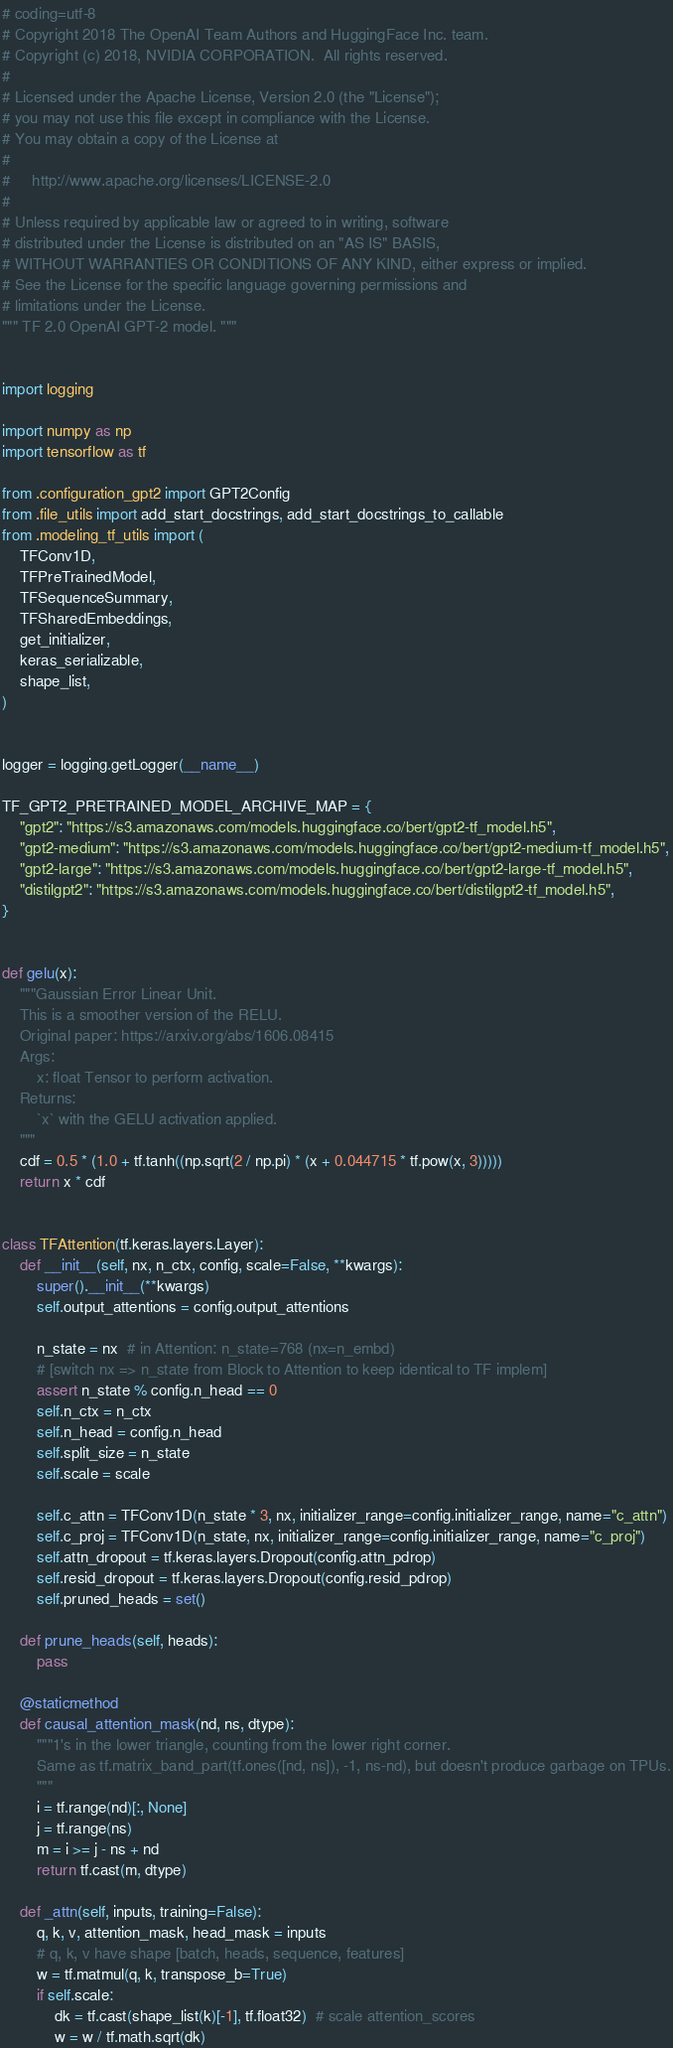<code> <loc_0><loc_0><loc_500><loc_500><_Python_># coding=utf-8
# Copyright 2018 The OpenAI Team Authors and HuggingFace Inc. team.
# Copyright (c) 2018, NVIDIA CORPORATION.  All rights reserved.
#
# Licensed under the Apache License, Version 2.0 (the "License");
# you may not use this file except in compliance with the License.
# You may obtain a copy of the License at
#
#     http://www.apache.org/licenses/LICENSE-2.0
#
# Unless required by applicable law or agreed to in writing, software
# distributed under the License is distributed on an "AS IS" BASIS,
# WITHOUT WARRANTIES OR CONDITIONS OF ANY KIND, either express or implied.
# See the License for the specific language governing permissions and
# limitations under the License.
""" TF 2.0 OpenAI GPT-2 model. """


import logging

import numpy as np
import tensorflow as tf

from .configuration_gpt2 import GPT2Config
from .file_utils import add_start_docstrings, add_start_docstrings_to_callable
from .modeling_tf_utils import (
    TFConv1D,
    TFPreTrainedModel,
    TFSequenceSummary,
    TFSharedEmbeddings,
    get_initializer,
    keras_serializable,
    shape_list,
)


logger = logging.getLogger(__name__)

TF_GPT2_PRETRAINED_MODEL_ARCHIVE_MAP = {
    "gpt2": "https://s3.amazonaws.com/models.huggingface.co/bert/gpt2-tf_model.h5",
    "gpt2-medium": "https://s3.amazonaws.com/models.huggingface.co/bert/gpt2-medium-tf_model.h5",
    "gpt2-large": "https://s3.amazonaws.com/models.huggingface.co/bert/gpt2-large-tf_model.h5",
    "distilgpt2": "https://s3.amazonaws.com/models.huggingface.co/bert/distilgpt2-tf_model.h5",
}


def gelu(x):
    """Gaussian Error Linear Unit.
    This is a smoother version of the RELU.
    Original paper: https://arxiv.org/abs/1606.08415
    Args:
        x: float Tensor to perform activation.
    Returns:
        `x` with the GELU activation applied.
    """
    cdf = 0.5 * (1.0 + tf.tanh((np.sqrt(2 / np.pi) * (x + 0.044715 * tf.pow(x, 3)))))
    return x * cdf


class TFAttention(tf.keras.layers.Layer):
    def __init__(self, nx, n_ctx, config, scale=False, **kwargs):
        super().__init__(**kwargs)
        self.output_attentions = config.output_attentions

        n_state = nx  # in Attention: n_state=768 (nx=n_embd)
        # [switch nx => n_state from Block to Attention to keep identical to TF implem]
        assert n_state % config.n_head == 0
        self.n_ctx = n_ctx
        self.n_head = config.n_head
        self.split_size = n_state
        self.scale = scale

        self.c_attn = TFConv1D(n_state * 3, nx, initializer_range=config.initializer_range, name="c_attn")
        self.c_proj = TFConv1D(n_state, nx, initializer_range=config.initializer_range, name="c_proj")
        self.attn_dropout = tf.keras.layers.Dropout(config.attn_pdrop)
        self.resid_dropout = tf.keras.layers.Dropout(config.resid_pdrop)
        self.pruned_heads = set()

    def prune_heads(self, heads):
        pass

    @staticmethod
    def causal_attention_mask(nd, ns, dtype):
        """1's in the lower triangle, counting from the lower right corner.
        Same as tf.matrix_band_part(tf.ones([nd, ns]), -1, ns-nd), but doesn't produce garbage on TPUs.
        """
        i = tf.range(nd)[:, None]
        j = tf.range(ns)
        m = i >= j - ns + nd
        return tf.cast(m, dtype)

    def _attn(self, inputs, training=False):
        q, k, v, attention_mask, head_mask = inputs
        # q, k, v have shape [batch, heads, sequence, features]
        w = tf.matmul(q, k, transpose_b=True)
        if self.scale:
            dk = tf.cast(shape_list(k)[-1], tf.float32)  # scale attention_scores
            w = w / tf.math.sqrt(dk)
</code> 